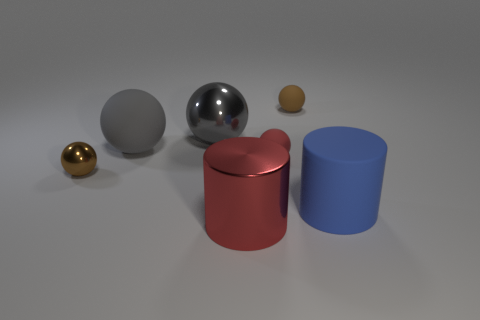Add 1 large yellow spheres. How many objects exist? 8 Subtract all large metal balls. How many balls are left? 4 Subtract all brown blocks. How many brown spheres are left? 2 Subtract 3 balls. How many balls are left? 2 Subtract all brown balls. How many balls are left? 3 Subtract all cylinders. How many objects are left? 5 Subtract 0 purple balls. How many objects are left? 7 Subtract all purple spheres. Subtract all cyan cylinders. How many spheres are left? 5 Subtract all tiny green matte objects. Subtract all blue things. How many objects are left? 6 Add 1 big red shiny things. How many big red shiny things are left? 2 